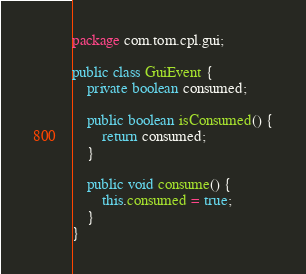Convert code to text. <code><loc_0><loc_0><loc_500><loc_500><_Java_>package com.tom.cpl.gui;

public class GuiEvent {
	private boolean consumed;

	public boolean isConsumed() {
		return consumed;
	}

	public void consume() {
		this.consumed = true;
	}
}</code> 